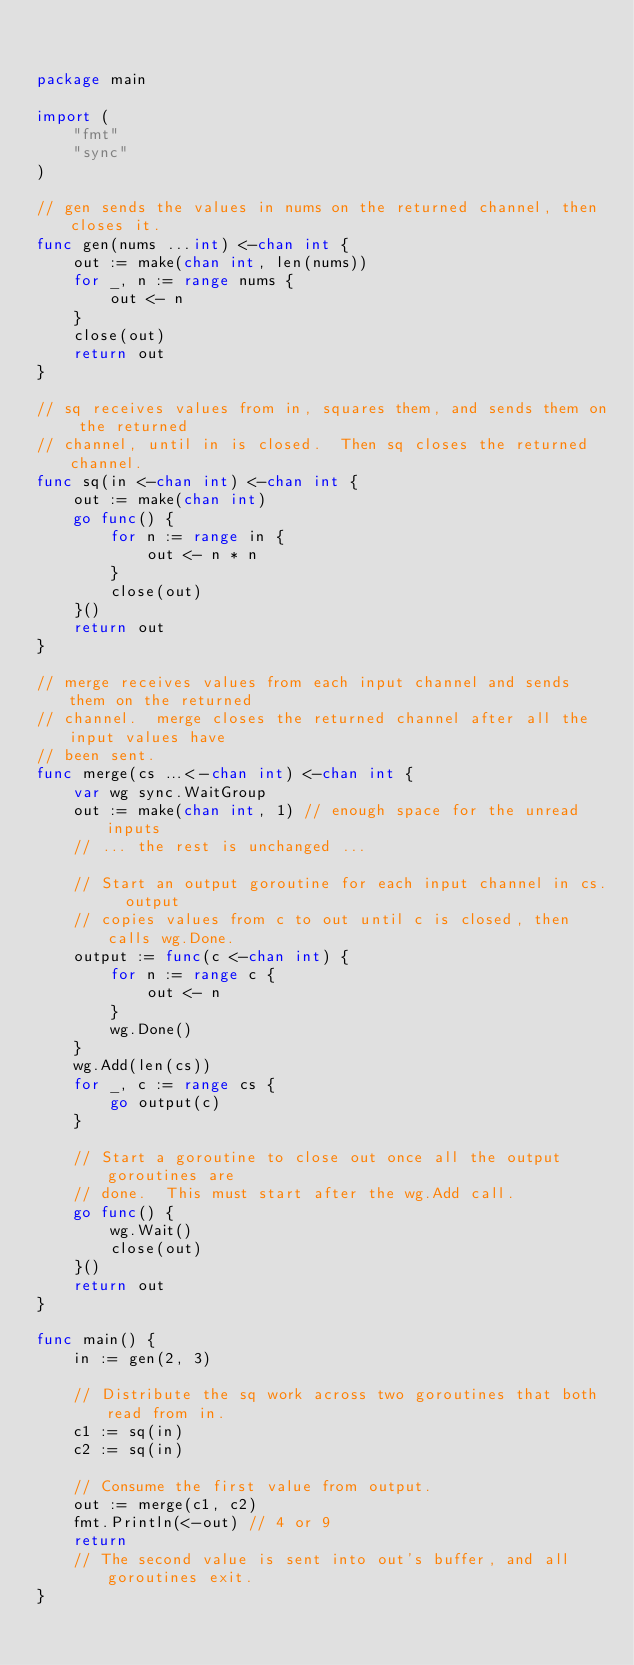Convert code to text. <code><loc_0><loc_0><loc_500><loc_500><_Go_>

package main

import (
	"fmt"
	"sync"
)

// gen sends the values in nums on the returned channel, then closes it.
func gen(nums ...int) <-chan int {
	out := make(chan int, len(nums))
	for _, n := range nums {
		out <- n
	}
	close(out)
	return out
}

// sq receives values from in, squares them, and sends them on the returned
// channel, until in is closed.  Then sq closes the returned channel.
func sq(in <-chan int) <-chan int {
	out := make(chan int)
	go func() {
		for n := range in {
			out <- n * n
		}
		close(out)
	}()
	return out
}

// merge receives values from each input channel and sends them on the returned
// channel.  merge closes the returned channel after all the input values have
// been sent.
func merge(cs ...<-chan int) <-chan int {
	var wg sync.WaitGroup
	out := make(chan int, 1) // enough space for the unread inputs
	// ... the rest is unchanged ...

	// Start an output goroutine for each input channel in cs.  output
	// copies values from c to out until c is closed, then calls wg.Done.
	output := func(c <-chan int) {
		for n := range c {
			out <- n
		}
		wg.Done()
	}
	wg.Add(len(cs))
	for _, c := range cs {
		go output(c)
	}

	// Start a goroutine to close out once all the output goroutines are
	// done.  This must start after the wg.Add call.
	go func() {
		wg.Wait()
		close(out)
	}()
	return out
}

func main() {
	in := gen(2, 3)

	// Distribute the sq work across two goroutines that both read from in.
	c1 := sq(in)
	c2 := sq(in)

	// Consume the first value from output.
	out := merge(c1, c2)
	fmt.Println(<-out) // 4 or 9
	return
	// The second value is sent into out's buffer, and all goroutines exit.
}
</code> 